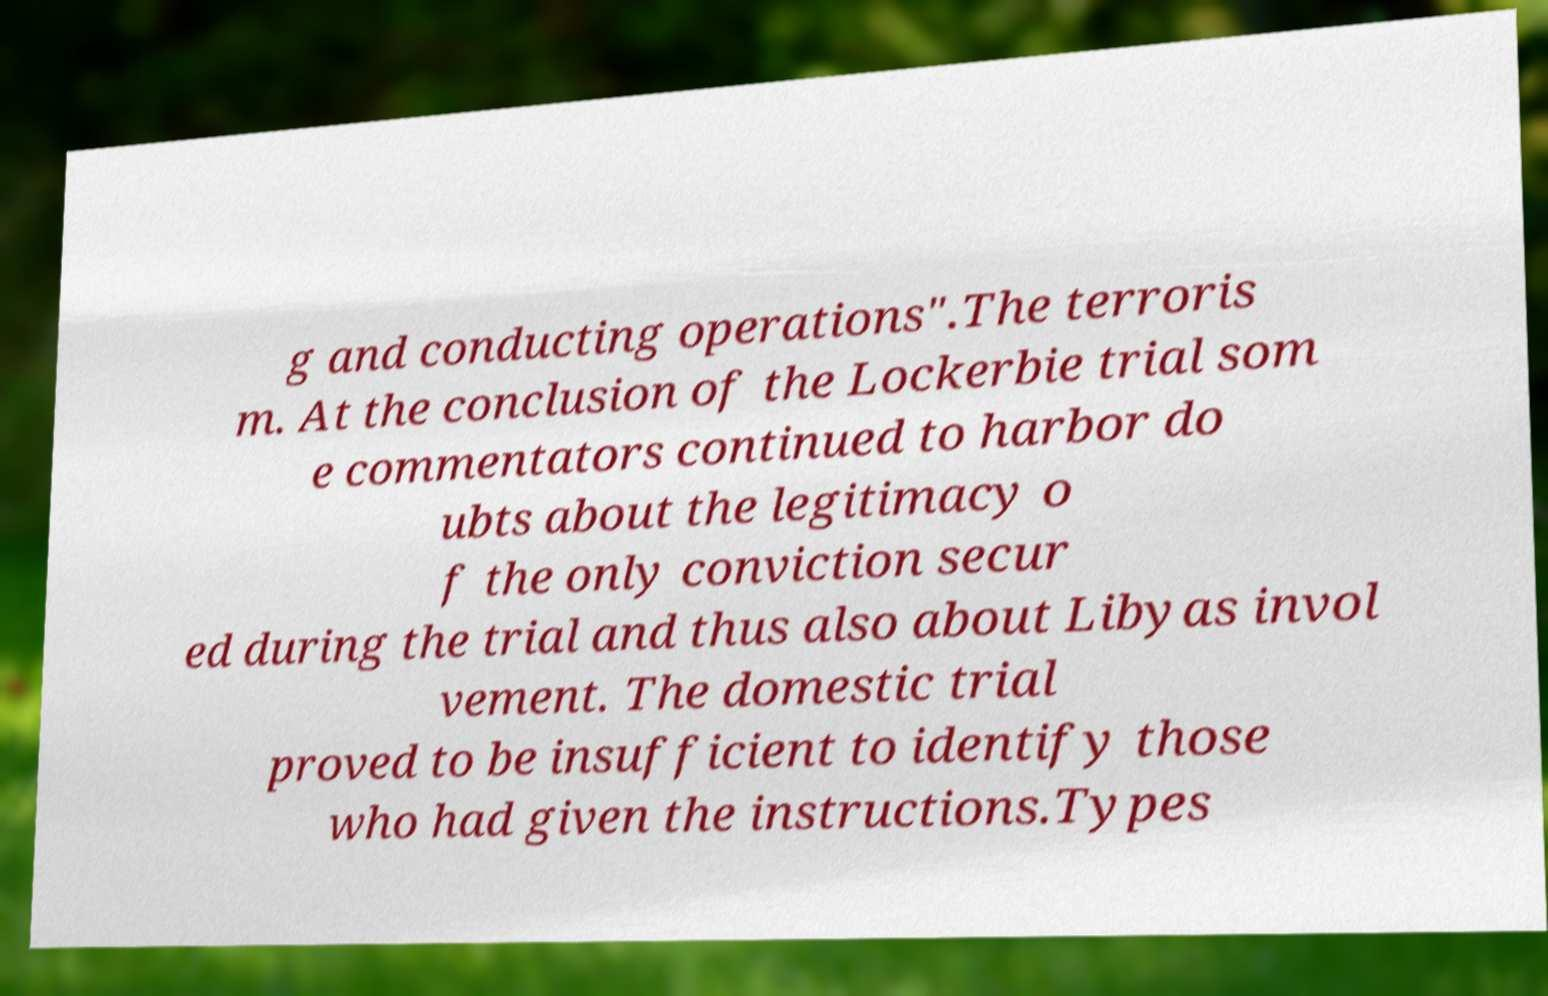There's text embedded in this image that I need extracted. Can you transcribe it verbatim? g and conducting operations".The terroris m. At the conclusion of the Lockerbie trial som e commentators continued to harbor do ubts about the legitimacy o f the only conviction secur ed during the trial and thus also about Libyas invol vement. The domestic trial proved to be insufficient to identify those who had given the instructions.Types 